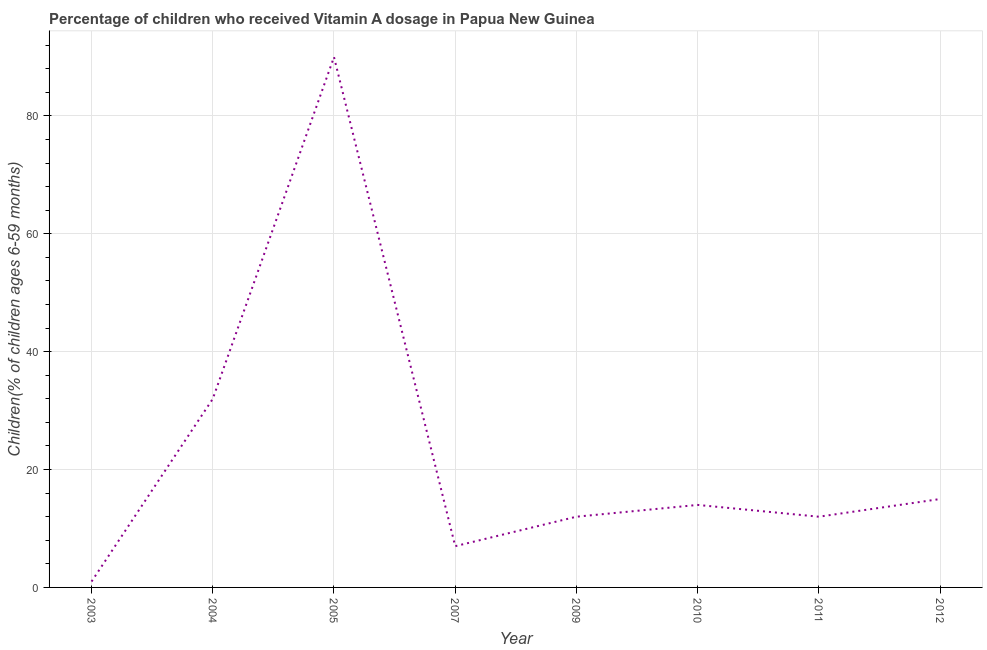What is the vitamin a supplementation coverage rate in 2003?
Ensure brevity in your answer.  1. Across all years, what is the maximum vitamin a supplementation coverage rate?
Ensure brevity in your answer.  90. Across all years, what is the minimum vitamin a supplementation coverage rate?
Your answer should be very brief. 1. In which year was the vitamin a supplementation coverage rate minimum?
Provide a succinct answer. 2003. What is the sum of the vitamin a supplementation coverage rate?
Keep it short and to the point. 183. What is the difference between the vitamin a supplementation coverage rate in 2007 and 2010?
Your answer should be very brief. -7. What is the average vitamin a supplementation coverage rate per year?
Offer a very short reply. 22.88. In how many years, is the vitamin a supplementation coverage rate greater than 28 %?
Give a very brief answer. 2. What is the ratio of the vitamin a supplementation coverage rate in 2004 to that in 2005?
Give a very brief answer. 0.36. Is the vitamin a supplementation coverage rate in 2003 less than that in 2011?
Provide a short and direct response. Yes. Is the difference between the vitamin a supplementation coverage rate in 2003 and 2005 greater than the difference between any two years?
Your response must be concise. Yes. What is the difference between the highest and the second highest vitamin a supplementation coverage rate?
Offer a very short reply. 58. What is the difference between the highest and the lowest vitamin a supplementation coverage rate?
Ensure brevity in your answer.  89. In how many years, is the vitamin a supplementation coverage rate greater than the average vitamin a supplementation coverage rate taken over all years?
Provide a succinct answer. 2. Does the vitamin a supplementation coverage rate monotonically increase over the years?
Ensure brevity in your answer.  No. Does the graph contain grids?
Your answer should be very brief. Yes. What is the title of the graph?
Give a very brief answer. Percentage of children who received Vitamin A dosage in Papua New Guinea. What is the label or title of the X-axis?
Provide a succinct answer. Year. What is the label or title of the Y-axis?
Ensure brevity in your answer.  Children(% of children ages 6-59 months). What is the Children(% of children ages 6-59 months) of 2003?
Ensure brevity in your answer.  1. What is the Children(% of children ages 6-59 months) of 2004?
Provide a short and direct response. 32. What is the Children(% of children ages 6-59 months) of 2005?
Your answer should be compact. 90. What is the Children(% of children ages 6-59 months) of 2007?
Your answer should be compact. 7. What is the Children(% of children ages 6-59 months) of 2010?
Give a very brief answer. 14. What is the Children(% of children ages 6-59 months) of 2011?
Your response must be concise. 12. What is the difference between the Children(% of children ages 6-59 months) in 2003 and 2004?
Your answer should be very brief. -31. What is the difference between the Children(% of children ages 6-59 months) in 2003 and 2005?
Offer a very short reply. -89. What is the difference between the Children(% of children ages 6-59 months) in 2003 and 2009?
Make the answer very short. -11. What is the difference between the Children(% of children ages 6-59 months) in 2003 and 2010?
Your answer should be compact. -13. What is the difference between the Children(% of children ages 6-59 months) in 2003 and 2012?
Give a very brief answer. -14. What is the difference between the Children(% of children ages 6-59 months) in 2004 and 2005?
Your answer should be compact. -58. What is the difference between the Children(% of children ages 6-59 months) in 2004 and 2009?
Your answer should be compact. 20. What is the difference between the Children(% of children ages 6-59 months) in 2004 and 2010?
Keep it short and to the point. 18. What is the difference between the Children(% of children ages 6-59 months) in 2004 and 2012?
Your answer should be very brief. 17. What is the difference between the Children(% of children ages 6-59 months) in 2005 and 2007?
Give a very brief answer. 83. What is the difference between the Children(% of children ages 6-59 months) in 2005 and 2010?
Offer a terse response. 76. What is the difference between the Children(% of children ages 6-59 months) in 2005 and 2012?
Provide a short and direct response. 75. What is the difference between the Children(% of children ages 6-59 months) in 2007 and 2011?
Your answer should be very brief. -5. What is the difference between the Children(% of children ages 6-59 months) in 2009 and 2010?
Make the answer very short. -2. What is the difference between the Children(% of children ages 6-59 months) in 2009 and 2012?
Offer a very short reply. -3. What is the difference between the Children(% of children ages 6-59 months) in 2011 and 2012?
Offer a terse response. -3. What is the ratio of the Children(% of children ages 6-59 months) in 2003 to that in 2004?
Give a very brief answer. 0.03. What is the ratio of the Children(% of children ages 6-59 months) in 2003 to that in 2005?
Make the answer very short. 0.01. What is the ratio of the Children(% of children ages 6-59 months) in 2003 to that in 2007?
Ensure brevity in your answer.  0.14. What is the ratio of the Children(% of children ages 6-59 months) in 2003 to that in 2009?
Provide a succinct answer. 0.08. What is the ratio of the Children(% of children ages 6-59 months) in 2003 to that in 2010?
Ensure brevity in your answer.  0.07. What is the ratio of the Children(% of children ages 6-59 months) in 2003 to that in 2011?
Your answer should be compact. 0.08. What is the ratio of the Children(% of children ages 6-59 months) in 2003 to that in 2012?
Provide a succinct answer. 0.07. What is the ratio of the Children(% of children ages 6-59 months) in 2004 to that in 2005?
Offer a terse response. 0.36. What is the ratio of the Children(% of children ages 6-59 months) in 2004 to that in 2007?
Ensure brevity in your answer.  4.57. What is the ratio of the Children(% of children ages 6-59 months) in 2004 to that in 2009?
Provide a succinct answer. 2.67. What is the ratio of the Children(% of children ages 6-59 months) in 2004 to that in 2010?
Offer a very short reply. 2.29. What is the ratio of the Children(% of children ages 6-59 months) in 2004 to that in 2011?
Keep it short and to the point. 2.67. What is the ratio of the Children(% of children ages 6-59 months) in 2004 to that in 2012?
Your response must be concise. 2.13. What is the ratio of the Children(% of children ages 6-59 months) in 2005 to that in 2007?
Offer a very short reply. 12.86. What is the ratio of the Children(% of children ages 6-59 months) in 2005 to that in 2009?
Ensure brevity in your answer.  7.5. What is the ratio of the Children(% of children ages 6-59 months) in 2005 to that in 2010?
Ensure brevity in your answer.  6.43. What is the ratio of the Children(% of children ages 6-59 months) in 2007 to that in 2009?
Keep it short and to the point. 0.58. What is the ratio of the Children(% of children ages 6-59 months) in 2007 to that in 2011?
Your answer should be compact. 0.58. What is the ratio of the Children(% of children ages 6-59 months) in 2007 to that in 2012?
Your answer should be compact. 0.47. What is the ratio of the Children(% of children ages 6-59 months) in 2009 to that in 2010?
Provide a short and direct response. 0.86. What is the ratio of the Children(% of children ages 6-59 months) in 2009 to that in 2011?
Your answer should be compact. 1. What is the ratio of the Children(% of children ages 6-59 months) in 2009 to that in 2012?
Offer a terse response. 0.8. What is the ratio of the Children(% of children ages 6-59 months) in 2010 to that in 2011?
Give a very brief answer. 1.17. What is the ratio of the Children(% of children ages 6-59 months) in 2010 to that in 2012?
Keep it short and to the point. 0.93. What is the ratio of the Children(% of children ages 6-59 months) in 2011 to that in 2012?
Give a very brief answer. 0.8. 